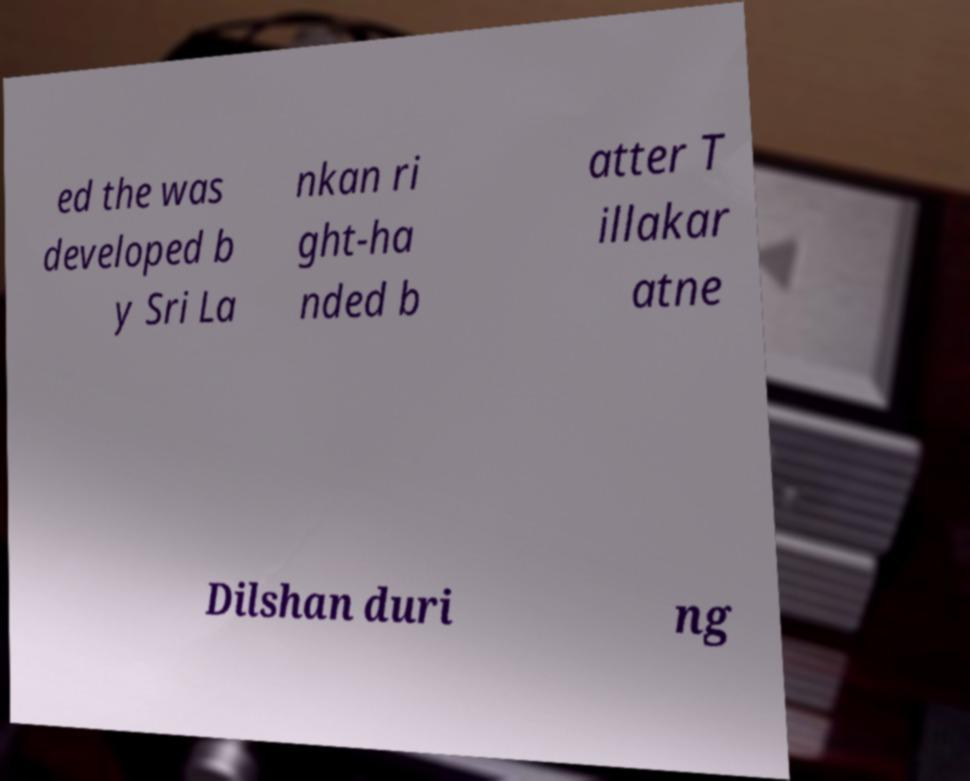I need the written content from this picture converted into text. Can you do that? ed the was developed b y Sri La nkan ri ght-ha nded b atter T illakar atne Dilshan duri ng 